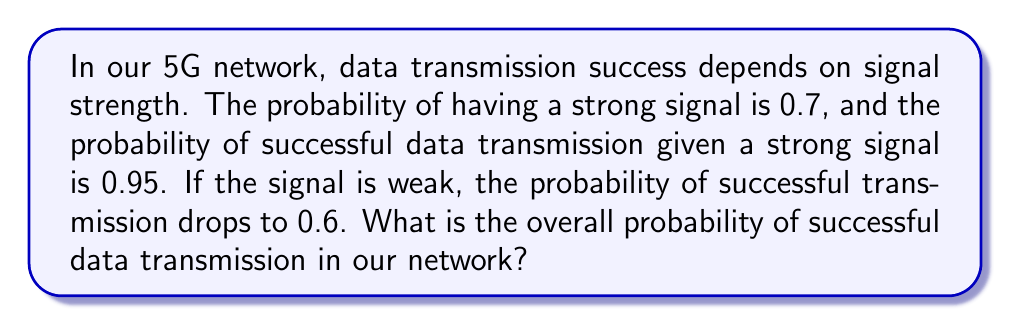Solve this math problem. Let's approach this step-by-step using conditional probability:

1) Define events:
   S: Strong signal
   W: Weak signal
   T: Successful transmission

2) Given probabilities:
   P(S) = 0.7 (probability of strong signal)
   P(W) = 1 - P(S) = 0.3 (probability of weak signal)
   P(T|S) = 0.95 (probability of successful transmission given strong signal)
   P(T|W) = 0.6 (probability of successful transmission given weak signal)

3) Use the law of total probability:
   P(T) = P(T|S) * P(S) + P(T|W) * P(W)

4) Substitute the values:
   P(T) = 0.95 * 0.7 + 0.6 * 0.3

5) Calculate:
   P(T) = 0.665 + 0.18 = 0.845

Therefore, the overall probability of successful data transmission is 0.845 or 84.5%.
Answer: 0.845 